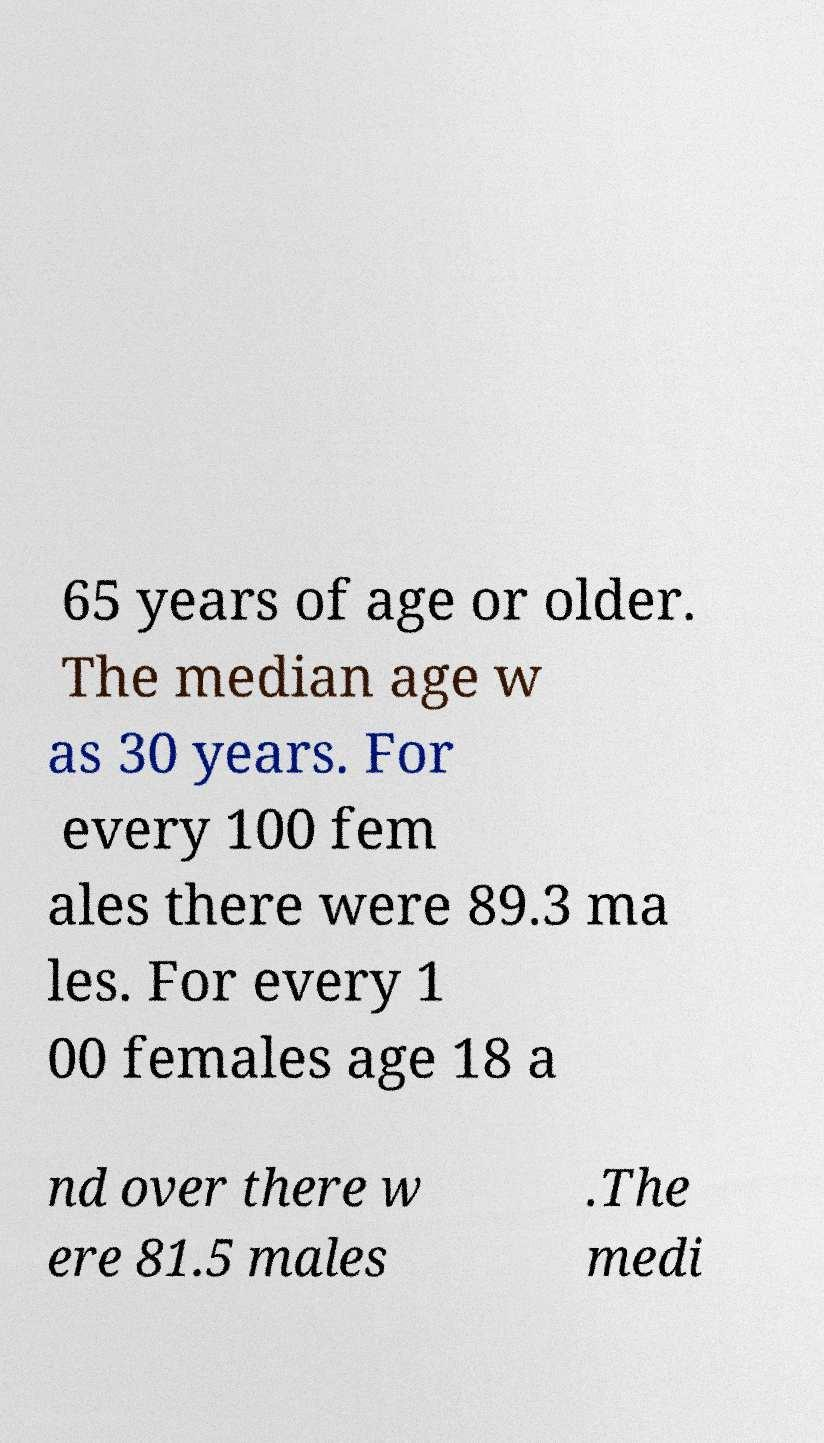Can you read and provide the text displayed in the image?This photo seems to have some interesting text. Can you extract and type it out for me? 65 years of age or older. The median age w as 30 years. For every 100 fem ales there were 89.3 ma les. For every 1 00 females age 18 a nd over there w ere 81.5 males .The medi 